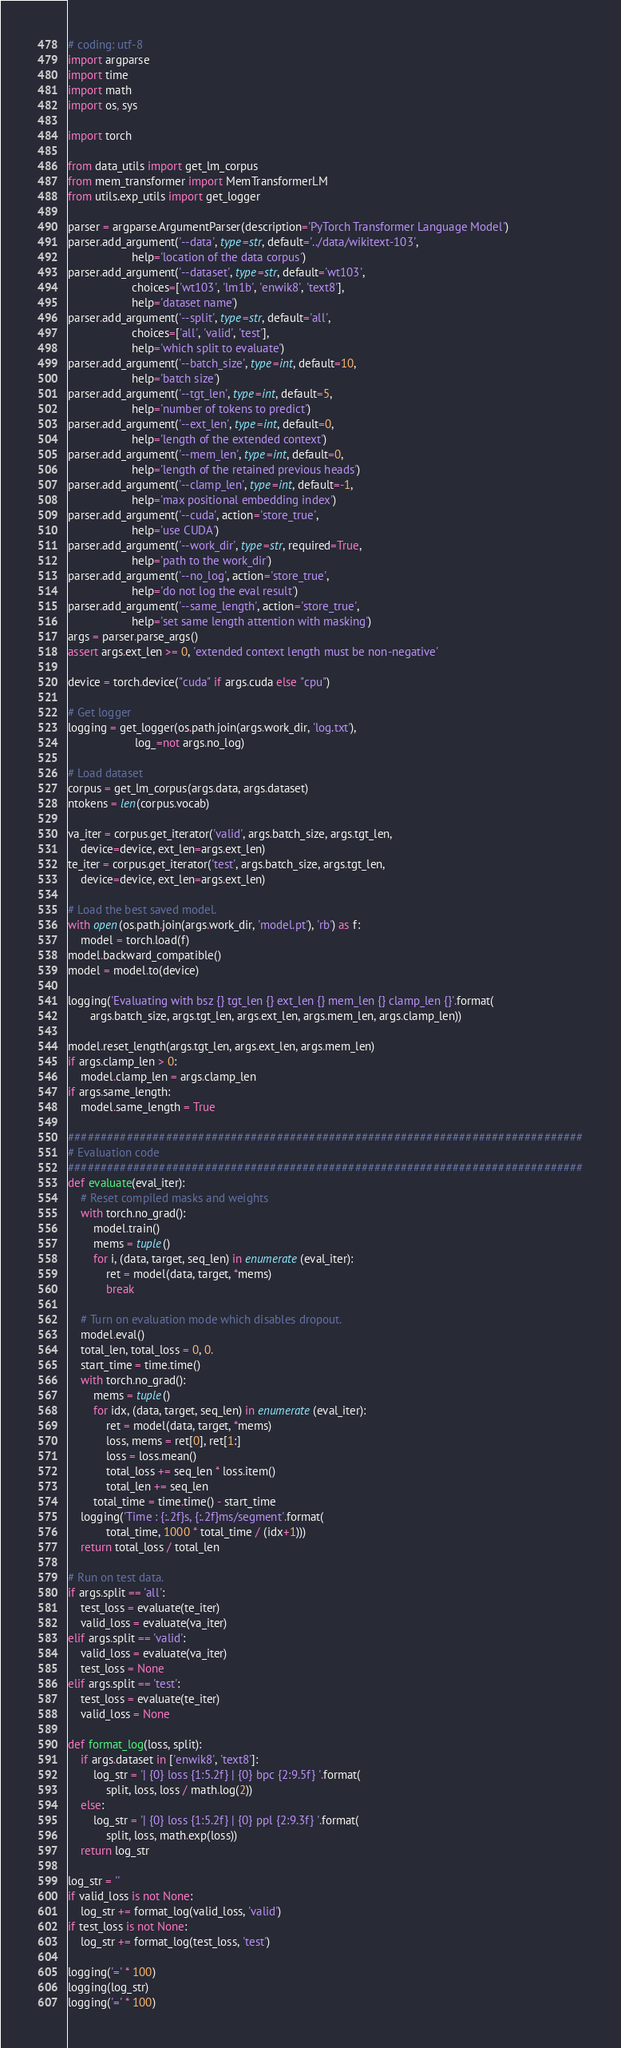<code> <loc_0><loc_0><loc_500><loc_500><_Python_># coding: utf-8
import argparse
import time
import math
import os, sys

import torch

from data_utils import get_lm_corpus
from mem_transformer import MemTransformerLM
from utils.exp_utils import get_logger

parser = argparse.ArgumentParser(description='PyTorch Transformer Language Model')
parser.add_argument('--data', type=str, default='../data/wikitext-103',
                    help='location of the data corpus')
parser.add_argument('--dataset', type=str, default='wt103',
                    choices=['wt103', 'lm1b', 'enwik8', 'text8'],
                    help='dataset name')
parser.add_argument('--split', type=str, default='all',
                    choices=['all', 'valid', 'test'],
                    help='which split to evaluate')
parser.add_argument('--batch_size', type=int, default=10,
                    help='batch size')
parser.add_argument('--tgt_len', type=int, default=5,
                    help='number of tokens to predict')
parser.add_argument('--ext_len', type=int, default=0,
                    help='length of the extended context')
parser.add_argument('--mem_len', type=int, default=0,
                    help='length of the retained previous heads')
parser.add_argument('--clamp_len', type=int, default=-1,
                    help='max positional embedding index')
parser.add_argument('--cuda', action='store_true',
                    help='use CUDA')
parser.add_argument('--work_dir', type=str, required=True,
                    help='path to the work_dir')
parser.add_argument('--no_log', action='store_true',
                    help='do not log the eval result')
parser.add_argument('--same_length', action='store_true',
                    help='set same length attention with masking')
args = parser.parse_args()
assert args.ext_len >= 0, 'extended context length must be non-negative'

device = torch.device("cuda" if args.cuda else "cpu")

# Get logger
logging = get_logger(os.path.join(args.work_dir, 'log.txt'),
                     log_=not args.no_log)

# Load dataset
corpus = get_lm_corpus(args.data, args.dataset)
ntokens = len(corpus.vocab)

va_iter = corpus.get_iterator('valid', args.batch_size, args.tgt_len,
    device=device, ext_len=args.ext_len)
te_iter = corpus.get_iterator('test', args.batch_size, args.tgt_len,
    device=device, ext_len=args.ext_len)

# Load the best saved model.
with open(os.path.join(args.work_dir, 'model.pt'), 'rb') as f:
    model = torch.load(f)
model.backward_compatible()
model = model.to(device)

logging('Evaluating with bsz {} tgt_len {} ext_len {} mem_len {} clamp_len {}'.format(
       args.batch_size, args.tgt_len, args.ext_len, args.mem_len, args.clamp_len))

model.reset_length(args.tgt_len, args.ext_len, args.mem_len)
if args.clamp_len > 0:
    model.clamp_len = args.clamp_len
if args.same_length:
    model.same_length = True

###############################################################################
# Evaluation code
###############################################################################
def evaluate(eval_iter):
    # Reset compiled masks and weights
    with torch.no_grad():
        model.train()
        mems = tuple()
        for i, (data, target, seq_len) in enumerate(eval_iter):
            ret = model(data, target, *mems)
            break

    # Turn on evaluation mode which disables dropout.
    model.eval()
    total_len, total_loss = 0, 0.
    start_time = time.time()
    with torch.no_grad():
        mems = tuple()
        for idx, (data, target, seq_len) in enumerate(eval_iter):
            ret = model(data, target, *mems)
            loss, mems = ret[0], ret[1:]
            loss = loss.mean()
            total_loss += seq_len * loss.item()
            total_len += seq_len
        total_time = time.time() - start_time
    logging('Time : {:.2f}s, {:.2f}ms/segment'.format(
            total_time, 1000 * total_time / (idx+1)))
    return total_loss / total_len

# Run on test data.
if args.split == 'all':
    test_loss = evaluate(te_iter)
    valid_loss = evaluate(va_iter)
elif args.split == 'valid':
    valid_loss = evaluate(va_iter)
    test_loss = None
elif args.split == 'test':
    test_loss = evaluate(te_iter)
    valid_loss = None

def format_log(loss, split):
    if args.dataset in ['enwik8', 'text8']:
        log_str = '| {0} loss {1:5.2f} | {0} bpc {2:9.5f} '.format(
            split, loss, loss / math.log(2))
    else:
        log_str = '| {0} loss {1:5.2f} | {0} ppl {2:9.3f} '.format(
            split, loss, math.exp(loss))
    return log_str

log_str = ''
if valid_loss is not None:
    log_str += format_log(valid_loss, 'valid')
if test_loss is not None:
    log_str += format_log(test_loss, 'test')

logging('=' * 100)
logging(log_str)
logging('=' * 100)
</code> 